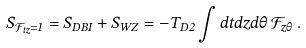<formula> <loc_0><loc_0><loc_500><loc_500>S _ { \mathcal { F } _ { t z } = 1 } = S _ { D B I } + S _ { W Z } = - T _ { D 2 } \int d t d z d \theta \, \mathcal { F } _ { z \theta } \, .</formula> 